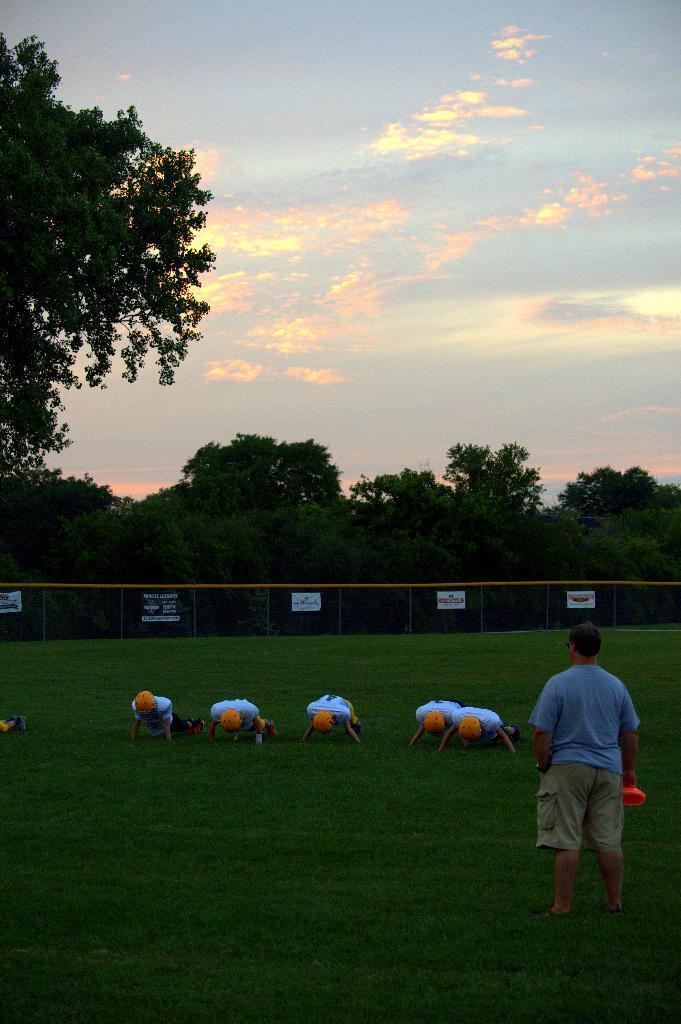Could you give a brief overview of what you see in this image? In this image we can see trees, fencing, people. To the right side of the image there is a person standing. At the bottom of the image there is grass. At the top of the image there is sky and clouds. 